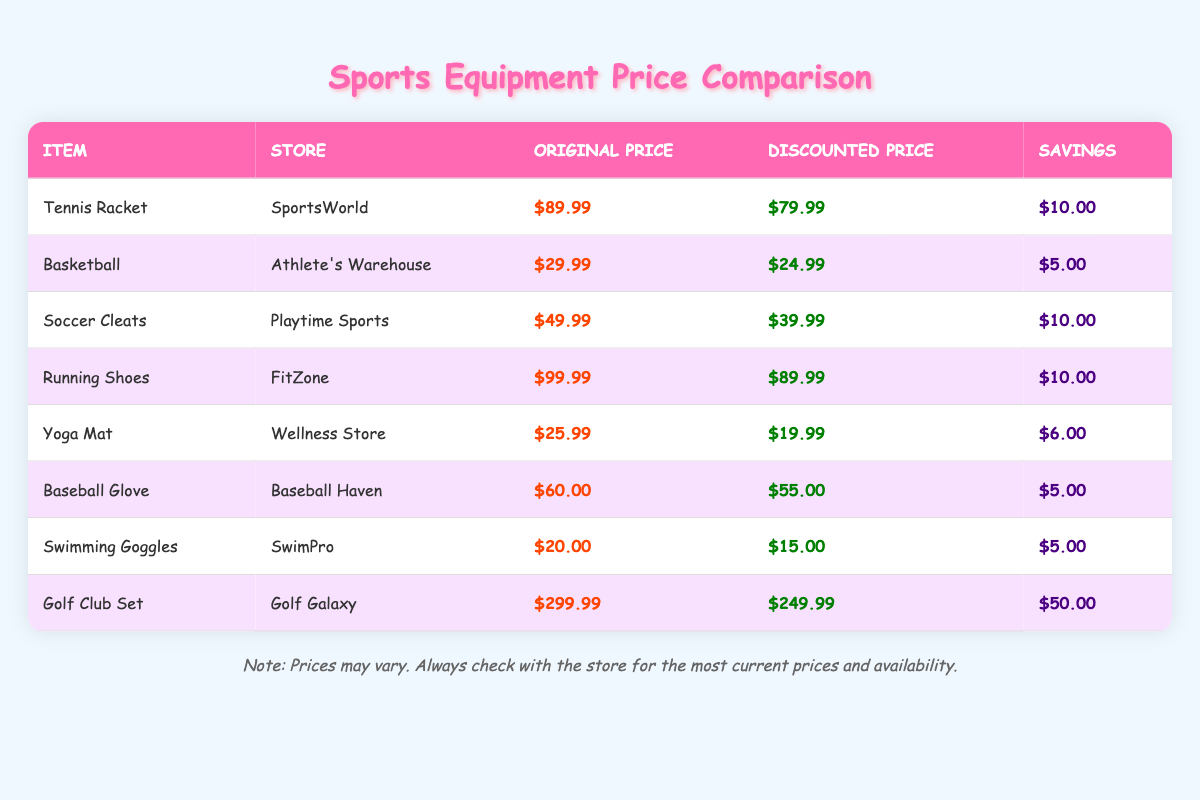What is the price of the Soccer Cleats at Playtime Sports? The table lists "Soccer Cleats" under Playtime Sports with a price of $49.99.
Answer: $49.99 What is the discounted price of the Yoga Mat? The Yoga Mat's discounted price displayed in the table is $19.99.
Answer: $19.99 Which item has the highest original price? The Golf Club Set has the highest original price of $299.99 according to the table.
Answer: Golf Club Set What is the total savings on the Tennis Racket and the Running Shoes? The savings for the Tennis Racket is $10.00, and for the Running Shoes, it is also $10.00. Adding them gives $10.00 + $10.00 = $20.00.
Answer: $20.00 Is the discounted price of the Basketball less than $25? The table shows the discounted price of the Basketball is $24.99, which is indeed less than $25.
Answer: Yes Which store offers the Swimming Goggles and what is the saving on them? The table indicates that SwimPro offers the Swimming Goggles for a discounted price of $15.00, saving $5.00.
Answer: SwimPro, $5.00 What is the average savings for all listed items? The savings for each item are $10.00, $5.00, $10.00, $10.00, $6.00, $5.00, $5.00, and $50.00. Adding these savings gives $91.00, and dividing by 8 items results in an average savings of $11.38.
Answer: $11.38 Which item offers the most significant savings, and how much is it? The Golf Club Set saves $50.00, which is the highest savings compared to the others listed in the table.
Answer: Golf Club Set, $50.00 What is the total of the original prices for items at Wellness Store and Baseball Haven? The original price at Wellness Store for Yoga Mat is $25.99, and at Baseball Haven for Baseball Glove is $60.00. Their total is $25.99 + $60.00 = $85.99.
Answer: $85.99 Is there a sport equipment item that has a discounted price equal to $15.00? Yes, the Swimming Goggles have a discounted price of $15.00 according to the table.
Answer: Yes 